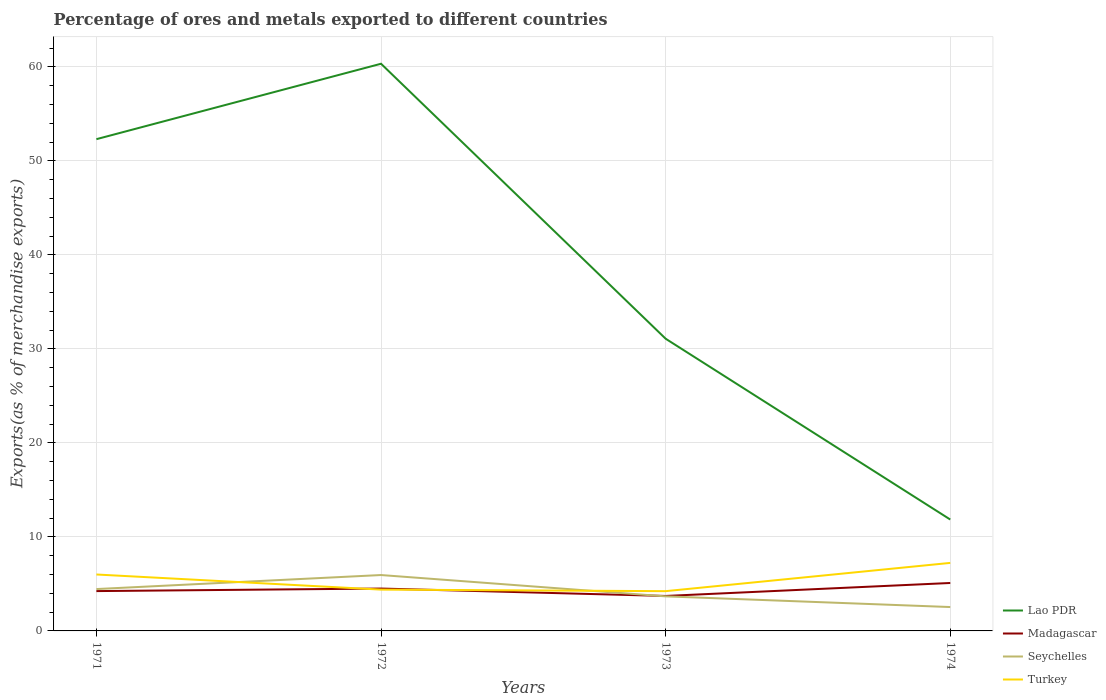Does the line corresponding to Madagascar intersect with the line corresponding to Turkey?
Provide a succinct answer. Yes. Across all years, what is the maximum percentage of exports to different countries in Turkey?
Make the answer very short. 4.23. In which year was the percentage of exports to different countries in Turkey maximum?
Offer a terse response. 1973. What is the total percentage of exports to different countries in Madagascar in the graph?
Offer a very short reply. 0.79. What is the difference between the highest and the second highest percentage of exports to different countries in Turkey?
Offer a terse response. 3.01. What is the difference between two consecutive major ticks on the Y-axis?
Ensure brevity in your answer.  10. Are the values on the major ticks of Y-axis written in scientific E-notation?
Keep it short and to the point. No. Where does the legend appear in the graph?
Ensure brevity in your answer.  Bottom right. How are the legend labels stacked?
Keep it short and to the point. Vertical. What is the title of the graph?
Offer a terse response. Percentage of ores and metals exported to different countries. Does "Qatar" appear as one of the legend labels in the graph?
Your answer should be compact. No. What is the label or title of the X-axis?
Provide a short and direct response. Years. What is the label or title of the Y-axis?
Your response must be concise. Exports(as % of merchandise exports). What is the Exports(as % of merchandise exports) of Lao PDR in 1971?
Keep it short and to the point. 52.32. What is the Exports(as % of merchandise exports) of Madagascar in 1971?
Your response must be concise. 4.24. What is the Exports(as % of merchandise exports) of Seychelles in 1971?
Your answer should be compact. 4.45. What is the Exports(as % of merchandise exports) of Turkey in 1971?
Provide a short and direct response. 6. What is the Exports(as % of merchandise exports) in Lao PDR in 1972?
Ensure brevity in your answer.  60.34. What is the Exports(as % of merchandise exports) of Madagascar in 1972?
Your answer should be compact. 4.51. What is the Exports(as % of merchandise exports) of Seychelles in 1972?
Give a very brief answer. 5.95. What is the Exports(as % of merchandise exports) in Turkey in 1972?
Make the answer very short. 4.4. What is the Exports(as % of merchandise exports) of Lao PDR in 1973?
Your answer should be compact. 31.09. What is the Exports(as % of merchandise exports) in Madagascar in 1973?
Your response must be concise. 3.72. What is the Exports(as % of merchandise exports) of Seychelles in 1973?
Offer a terse response. 3.68. What is the Exports(as % of merchandise exports) in Turkey in 1973?
Make the answer very short. 4.23. What is the Exports(as % of merchandise exports) of Lao PDR in 1974?
Ensure brevity in your answer.  11.85. What is the Exports(as % of merchandise exports) in Madagascar in 1974?
Ensure brevity in your answer.  5.1. What is the Exports(as % of merchandise exports) of Seychelles in 1974?
Ensure brevity in your answer.  2.54. What is the Exports(as % of merchandise exports) in Turkey in 1974?
Offer a very short reply. 7.24. Across all years, what is the maximum Exports(as % of merchandise exports) of Lao PDR?
Your answer should be very brief. 60.34. Across all years, what is the maximum Exports(as % of merchandise exports) of Madagascar?
Make the answer very short. 5.1. Across all years, what is the maximum Exports(as % of merchandise exports) in Seychelles?
Ensure brevity in your answer.  5.95. Across all years, what is the maximum Exports(as % of merchandise exports) of Turkey?
Keep it short and to the point. 7.24. Across all years, what is the minimum Exports(as % of merchandise exports) in Lao PDR?
Provide a short and direct response. 11.85. Across all years, what is the minimum Exports(as % of merchandise exports) of Madagascar?
Offer a very short reply. 3.72. Across all years, what is the minimum Exports(as % of merchandise exports) in Seychelles?
Provide a succinct answer. 2.54. Across all years, what is the minimum Exports(as % of merchandise exports) of Turkey?
Keep it short and to the point. 4.23. What is the total Exports(as % of merchandise exports) in Lao PDR in the graph?
Provide a succinct answer. 155.59. What is the total Exports(as % of merchandise exports) of Madagascar in the graph?
Make the answer very short. 17.56. What is the total Exports(as % of merchandise exports) of Seychelles in the graph?
Your answer should be very brief. 16.61. What is the total Exports(as % of merchandise exports) of Turkey in the graph?
Keep it short and to the point. 21.86. What is the difference between the Exports(as % of merchandise exports) of Lao PDR in 1971 and that in 1972?
Give a very brief answer. -8.03. What is the difference between the Exports(as % of merchandise exports) of Madagascar in 1971 and that in 1972?
Ensure brevity in your answer.  -0.27. What is the difference between the Exports(as % of merchandise exports) of Seychelles in 1971 and that in 1972?
Provide a succinct answer. -1.49. What is the difference between the Exports(as % of merchandise exports) of Turkey in 1971 and that in 1972?
Provide a short and direct response. 1.61. What is the difference between the Exports(as % of merchandise exports) in Lao PDR in 1971 and that in 1973?
Your answer should be compact. 21.23. What is the difference between the Exports(as % of merchandise exports) of Madagascar in 1971 and that in 1973?
Make the answer very short. 0.52. What is the difference between the Exports(as % of merchandise exports) in Seychelles in 1971 and that in 1973?
Your answer should be compact. 0.78. What is the difference between the Exports(as % of merchandise exports) in Turkey in 1971 and that in 1973?
Your answer should be compact. 1.77. What is the difference between the Exports(as % of merchandise exports) in Lao PDR in 1971 and that in 1974?
Ensure brevity in your answer.  40.47. What is the difference between the Exports(as % of merchandise exports) in Madagascar in 1971 and that in 1974?
Ensure brevity in your answer.  -0.86. What is the difference between the Exports(as % of merchandise exports) in Seychelles in 1971 and that in 1974?
Provide a short and direct response. 1.91. What is the difference between the Exports(as % of merchandise exports) in Turkey in 1971 and that in 1974?
Your response must be concise. -1.23. What is the difference between the Exports(as % of merchandise exports) of Lao PDR in 1972 and that in 1973?
Your answer should be compact. 29.25. What is the difference between the Exports(as % of merchandise exports) in Madagascar in 1972 and that in 1973?
Provide a succinct answer. 0.79. What is the difference between the Exports(as % of merchandise exports) of Seychelles in 1972 and that in 1973?
Give a very brief answer. 2.27. What is the difference between the Exports(as % of merchandise exports) in Turkey in 1972 and that in 1973?
Offer a terse response. 0.17. What is the difference between the Exports(as % of merchandise exports) in Lao PDR in 1972 and that in 1974?
Ensure brevity in your answer.  48.49. What is the difference between the Exports(as % of merchandise exports) in Madagascar in 1972 and that in 1974?
Ensure brevity in your answer.  -0.59. What is the difference between the Exports(as % of merchandise exports) of Seychelles in 1972 and that in 1974?
Give a very brief answer. 3.41. What is the difference between the Exports(as % of merchandise exports) in Turkey in 1972 and that in 1974?
Provide a short and direct response. -2.84. What is the difference between the Exports(as % of merchandise exports) in Lao PDR in 1973 and that in 1974?
Your answer should be compact. 19.24. What is the difference between the Exports(as % of merchandise exports) in Madagascar in 1973 and that in 1974?
Your answer should be compact. -1.38. What is the difference between the Exports(as % of merchandise exports) in Seychelles in 1973 and that in 1974?
Your response must be concise. 1.14. What is the difference between the Exports(as % of merchandise exports) in Turkey in 1973 and that in 1974?
Keep it short and to the point. -3.01. What is the difference between the Exports(as % of merchandise exports) in Lao PDR in 1971 and the Exports(as % of merchandise exports) in Madagascar in 1972?
Your answer should be compact. 47.81. What is the difference between the Exports(as % of merchandise exports) in Lao PDR in 1971 and the Exports(as % of merchandise exports) in Seychelles in 1972?
Offer a very short reply. 46.37. What is the difference between the Exports(as % of merchandise exports) of Lao PDR in 1971 and the Exports(as % of merchandise exports) of Turkey in 1972?
Provide a short and direct response. 47.92. What is the difference between the Exports(as % of merchandise exports) of Madagascar in 1971 and the Exports(as % of merchandise exports) of Seychelles in 1972?
Offer a terse response. -1.71. What is the difference between the Exports(as % of merchandise exports) in Madagascar in 1971 and the Exports(as % of merchandise exports) in Turkey in 1972?
Your answer should be very brief. -0.16. What is the difference between the Exports(as % of merchandise exports) in Seychelles in 1971 and the Exports(as % of merchandise exports) in Turkey in 1972?
Your answer should be compact. 0.06. What is the difference between the Exports(as % of merchandise exports) in Lao PDR in 1971 and the Exports(as % of merchandise exports) in Madagascar in 1973?
Offer a terse response. 48.6. What is the difference between the Exports(as % of merchandise exports) of Lao PDR in 1971 and the Exports(as % of merchandise exports) of Seychelles in 1973?
Your response must be concise. 48.64. What is the difference between the Exports(as % of merchandise exports) in Lao PDR in 1971 and the Exports(as % of merchandise exports) in Turkey in 1973?
Give a very brief answer. 48.09. What is the difference between the Exports(as % of merchandise exports) in Madagascar in 1971 and the Exports(as % of merchandise exports) in Seychelles in 1973?
Make the answer very short. 0.56. What is the difference between the Exports(as % of merchandise exports) of Madagascar in 1971 and the Exports(as % of merchandise exports) of Turkey in 1973?
Offer a very short reply. 0.01. What is the difference between the Exports(as % of merchandise exports) in Seychelles in 1971 and the Exports(as % of merchandise exports) in Turkey in 1973?
Ensure brevity in your answer.  0.22. What is the difference between the Exports(as % of merchandise exports) in Lao PDR in 1971 and the Exports(as % of merchandise exports) in Madagascar in 1974?
Provide a short and direct response. 47.22. What is the difference between the Exports(as % of merchandise exports) of Lao PDR in 1971 and the Exports(as % of merchandise exports) of Seychelles in 1974?
Ensure brevity in your answer.  49.78. What is the difference between the Exports(as % of merchandise exports) of Lao PDR in 1971 and the Exports(as % of merchandise exports) of Turkey in 1974?
Make the answer very short. 45.08. What is the difference between the Exports(as % of merchandise exports) of Madagascar in 1971 and the Exports(as % of merchandise exports) of Seychelles in 1974?
Your response must be concise. 1.7. What is the difference between the Exports(as % of merchandise exports) in Madagascar in 1971 and the Exports(as % of merchandise exports) in Turkey in 1974?
Your response must be concise. -3. What is the difference between the Exports(as % of merchandise exports) of Seychelles in 1971 and the Exports(as % of merchandise exports) of Turkey in 1974?
Your answer should be compact. -2.78. What is the difference between the Exports(as % of merchandise exports) in Lao PDR in 1972 and the Exports(as % of merchandise exports) in Madagascar in 1973?
Keep it short and to the point. 56.62. What is the difference between the Exports(as % of merchandise exports) in Lao PDR in 1972 and the Exports(as % of merchandise exports) in Seychelles in 1973?
Offer a terse response. 56.66. What is the difference between the Exports(as % of merchandise exports) of Lao PDR in 1972 and the Exports(as % of merchandise exports) of Turkey in 1973?
Your answer should be compact. 56.11. What is the difference between the Exports(as % of merchandise exports) in Madagascar in 1972 and the Exports(as % of merchandise exports) in Seychelles in 1973?
Ensure brevity in your answer.  0.83. What is the difference between the Exports(as % of merchandise exports) in Madagascar in 1972 and the Exports(as % of merchandise exports) in Turkey in 1973?
Your answer should be compact. 0.28. What is the difference between the Exports(as % of merchandise exports) of Seychelles in 1972 and the Exports(as % of merchandise exports) of Turkey in 1973?
Your answer should be compact. 1.72. What is the difference between the Exports(as % of merchandise exports) in Lao PDR in 1972 and the Exports(as % of merchandise exports) in Madagascar in 1974?
Offer a very short reply. 55.24. What is the difference between the Exports(as % of merchandise exports) in Lao PDR in 1972 and the Exports(as % of merchandise exports) in Seychelles in 1974?
Offer a terse response. 57.8. What is the difference between the Exports(as % of merchandise exports) in Lao PDR in 1972 and the Exports(as % of merchandise exports) in Turkey in 1974?
Offer a terse response. 53.1. What is the difference between the Exports(as % of merchandise exports) in Madagascar in 1972 and the Exports(as % of merchandise exports) in Seychelles in 1974?
Provide a short and direct response. 1.97. What is the difference between the Exports(as % of merchandise exports) of Madagascar in 1972 and the Exports(as % of merchandise exports) of Turkey in 1974?
Your response must be concise. -2.73. What is the difference between the Exports(as % of merchandise exports) of Seychelles in 1972 and the Exports(as % of merchandise exports) of Turkey in 1974?
Give a very brief answer. -1.29. What is the difference between the Exports(as % of merchandise exports) of Lao PDR in 1973 and the Exports(as % of merchandise exports) of Madagascar in 1974?
Offer a terse response. 25.99. What is the difference between the Exports(as % of merchandise exports) in Lao PDR in 1973 and the Exports(as % of merchandise exports) in Seychelles in 1974?
Give a very brief answer. 28.55. What is the difference between the Exports(as % of merchandise exports) of Lao PDR in 1973 and the Exports(as % of merchandise exports) of Turkey in 1974?
Give a very brief answer. 23.85. What is the difference between the Exports(as % of merchandise exports) in Madagascar in 1973 and the Exports(as % of merchandise exports) in Seychelles in 1974?
Offer a very short reply. 1.18. What is the difference between the Exports(as % of merchandise exports) in Madagascar in 1973 and the Exports(as % of merchandise exports) in Turkey in 1974?
Ensure brevity in your answer.  -3.52. What is the difference between the Exports(as % of merchandise exports) in Seychelles in 1973 and the Exports(as % of merchandise exports) in Turkey in 1974?
Keep it short and to the point. -3.56. What is the average Exports(as % of merchandise exports) of Lao PDR per year?
Your response must be concise. 38.9. What is the average Exports(as % of merchandise exports) of Madagascar per year?
Your answer should be compact. 4.39. What is the average Exports(as % of merchandise exports) of Seychelles per year?
Offer a very short reply. 4.15. What is the average Exports(as % of merchandise exports) of Turkey per year?
Offer a very short reply. 5.47. In the year 1971, what is the difference between the Exports(as % of merchandise exports) in Lao PDR and Exports(as % of merchandise exports) in Madagascar?
Your answer should be compact. 48.08. In the year 1971, what is the difference between the Exports(as % of merchandise exports) of Lao PDR and Exports(as % of merchandise exports) of Seychelles?
Your answer should be compact. 47.86. In the year 1971, what is the difference between the Exports(as % of merchandise exports) in Lao PDR and Exports(as % of merchandise exports) in Turkey?
Keep it short and to the point. 46.31. In the year 1971, what is the difference between the Exports(as % of merchandise exports) in Madagascar and Exports(as % of merchandise exports) in Seychelles?
Give a very brief answer. -0.22. In the year 1971, what is the difference between the Exports(as % of merchandise exports) of Madagascar and Exports(as % of merchandise exports) of Turkey?
Keep it short and to the point. -1.77. In the year 1971, what is the difference between the Exports(as % of merchandise exports) of Seychelles and Exports(as % of merchandise exports) of Turkey?
Give a very brief answer. -1.55. In the year 1972, what is the difference between the Exports(as % of merchandise exports) in Lao PDR and Exports(as % of merchandise exports) in Madagascar?
Keep it short and to the point. 55.83. In the year 1972, what is the difference between the Exports(as % of merchandise exports) in Lao PDR and Exports(as % of merchandise exports) in Seychelles?
Offer a terse response. 54.4. In the year 1972, what is the difference between the Exports(as % of merchandise exports) in Lao PDR and Exports(as % of merchandise exports) in Turkey?
Offer a very short reply. 55.95. In the year 1972, what is the difference between the Exports(as % of merchandise exports) in Madagascar and Exports(as % of merchandise exports) in Seychelles?
Keep it short and to the point. -1.44. In the year 1972, what is the difference between the Exports(as % of merchandise exports) in Madagascar and Exports(as % of merchandise exports) in Turkey?
Give a very brief answer. 0.11. In the year 1972, what is the difference between the Exports(as % of merchandise exports) of Seychelles and Exports(as % of merchandise exports) of Turkey?
Offer a terse response. 1.55. In the year 1973, what is the difference between the Exports(as % of merchandise exports) of Lao PDR and Exports(as % of merchandise exports) of Madagascar?
Ensure brevity in your answer.  27.37. In the year 1973, what is the difference between the Exports(as % of merchandise exports) in Lao PDR and Exports(as % of merchandise exports) in Seychelles?
Offer a terse response. 27.41. In the year 1973, what is the difference between the Exports(as % of merchandise exports) of Lao PDR and Exports(as % of merchandise exports) of Turkey?
Give a very brief answer. 26.86. In the year 1973, what is the difference between the Exports(as % of merchandise exports) of Madagascar and Exports(as % of merchandise exports) of Seychelles?
Provide a succinct answer. 0.04. In the year 1973, what is the difference between the Exports(as % of merchandise exports) of Madagascar and Exports(as % of merchandise exports) of Turkey?
Make the answer very short. -0.51. In the year 1973, what is the difference between the Exports(as % of merchandise exports) in Seychelles and Exports(as % of merchandise exports) in Turkey?
Offer a terse response. -0.55. In the year 1974, what is the difference between the Exports(as % of merchandise exports) of Lao PDR and Exports(as % of merchandise exports) of Madagascar?
Give a very brief answer. 6.75. In the year 1974, what is the difference between the Exports(as % of merchandise exports) of Lao PDR and Exports(as % of merchandise exports) of Seychelles?
Your answer should be compact. 9.31. In the year 1974, what is the difference between the Exports(as % of merchandise exports) of Lao PDR and Exports(as % of merchandise exports) of Turkey?
Provide a short and direct response. 4.61. In the year 1974, what is the difference between the Exports(as % of merchandise exports) in Madagascar and Exports(as % of merchandise exports) in Seychelles?
Offer a terse response. 2.56. In the year 1974, what is the difference between the Exports(as % of merchandise exports) in Madagascar and Exports(as % of merchandise exports) in Turkey?
Provide a short and direct response. -2.14. In the year 1974, what is the difference between the Exports(as % of merchandise exports) of Seychelles and Exports(as % of merchandise exports) of Turkey?
Give a very brief answer. -4.7. What is the ratio of the Exports(as % of merchandise exports) in Lao PDR in 1971 to that in 1972?
Provide a succinct answer. 0.87. What is the ratio of the Exports(as % of merchandise exports) in Madagascar in 1971 to that in 1972?
Your answer should be very brief. 0.94. What is the ratio of the Exports(as % of merchandise exports) of Seychelles in 1971 to that in 1972?
Your answer should be very brief. 0.75. What is the ratio of the Exports(as % of merchandise exports) in Turkey in 1971 to that in 1972?
Provide a succinct answer. 1.37. What is the ratio of the Exports(as % of merchandise exports) in Lao PDR in 1971 to that in 1973?
Give a very brief answer. 1.68. What is the ratio of the Exports(as % of merchandise exports) of Madagascar in 1971 to that in 1973?
Make the answer very short. 1.14. What is the ratio of the Exports(as % of merchandise exports) in Seychelles in 1971 to that in 1973?
Offer a terse response. 1.21. What is the ratio of the Exports(as % of merchandise exports) in Turkey in 1971 to that in 1973?
Provide a succinct answer. 1.42. What is the ratio of the Exports(as % of merchandise exports) of Lao PDR in 1971 to that in 1974?
Ensure brevity in your answer.  4.41. What is the ratio of the Exports(as % of merchandise exports) of Madagascar in 1971 to that in 1974?
Make the answer very short. 0.83. What is the ratio of the Exports(as % of merchandise exports) in Seychelles in 1971 to that in 1974?
Give a very brief answer. 1.75. What is the ratio of the Exports(as % of merchandise exports) of Turkey in 1971 to that in 1974?
Your answer should be very brief. 0.83. What is the ratio of the Exports(as % of merchandise exports) in Lao PDR in 1972 to that in 1973?
Make the answer very short. 1.94. What is the ratio of the Exports(as % of merchandise exports) of Madagascar in 1972 to that in 1973?
Keep it short and to the point. 1.21. What is the ratio of the Exports(as % of merchandise exports) in Seychelles in 1972 to that in 1973?
Give a very brief answer. 1.62. What is the ratio of the Exports(as % of merchandise exports) of Turkey in 1972 to that in 1973?
Your response must be concise. 1.04. What is the ratio of the Exports(as % of merchandise exports) in Lao PDR in 1972 to that in 1974?
Keep it short and to the point. 5.09. What is the ratio of the Exports(as % of merchandise exports) in Madagascar in 1972 to that in 1974?
Make the answer very short. 0.88. What is the ratio of the Exports(as % of merchandise exports) in Seychelles in 1972 to that in 1974?
Your answer should be compact. 2.34. What is the ratio of the Exports(as % of merchandise exports) in Turkey in 1972 to that in 1974?
Provide a short and direct response. 0.61. What is the ratio of the Exports(as % of merchandise exports) of Lao PDR in 1973 to that in 1974?
Your response must be concise. 2.62. What is the ratio of the Exports(as % of merchandise exports) of Madagascar in 1973 to that in 1974?
Offer a terse response. 0.73. What is the ratio of the Exports(as % of merchandise exports) of Seychelles in 1973 to that in 1974?
Ensure brevity in your answer.  1.45. What is the ratio of the Exports(as % of merchandise exports) in Turkey in 1973 to that in 1974?
Provide a short and direct response. 0.58. What is the difference between the highest and the second highest Exports(as % of merchandise exports) in Lao PDR?
Your response must be concise. 8.03. What is the difference between the highest and the second highest Exports(as % of merchandise exports) of Madagascar?
Offer a terse response. 0.59. What is the difference between the highest and the second highest Exports(as % of merchandise exports) in Seychelles?
Your answer should be very brief. 1.49. What is the difference between the highest and the second highest Exports(as % of merchandise exports) of Turkey?
Your answer should be very brief. 1.23. What is the difference between the highest and the lowest Exports(as % of merchandise exports) of Lao PDR?
Your answer should be very brief. 48.49. What is the difference between the highest and the lowest Exports(as % of merchandise exports) of Madagascar?
Make the answer very short. 1.38. What is the difference between the highest and the lowest Exports(as % of merchandise exports) of Seychelles?
Make the answer very short. 3.41. What is the difference between the highest and the lowest Exports(as % of merchandise exports) in Turkey?
Keep it short and to the point. 3.01. 